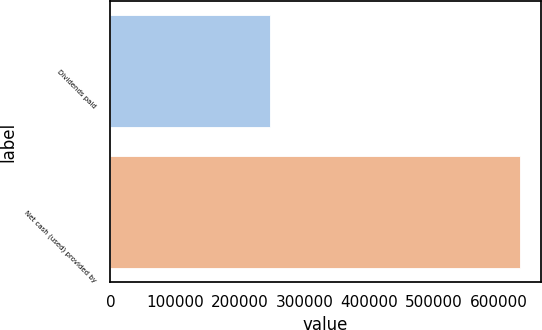Convert chart. <chart><loc_0><loc_0><loc_500><loc_500><bar_chart><fcel>Dividends paid<fcel>Net cash (used) provided by<nl><fcel>245810<fcel>632891<nl></chart> 